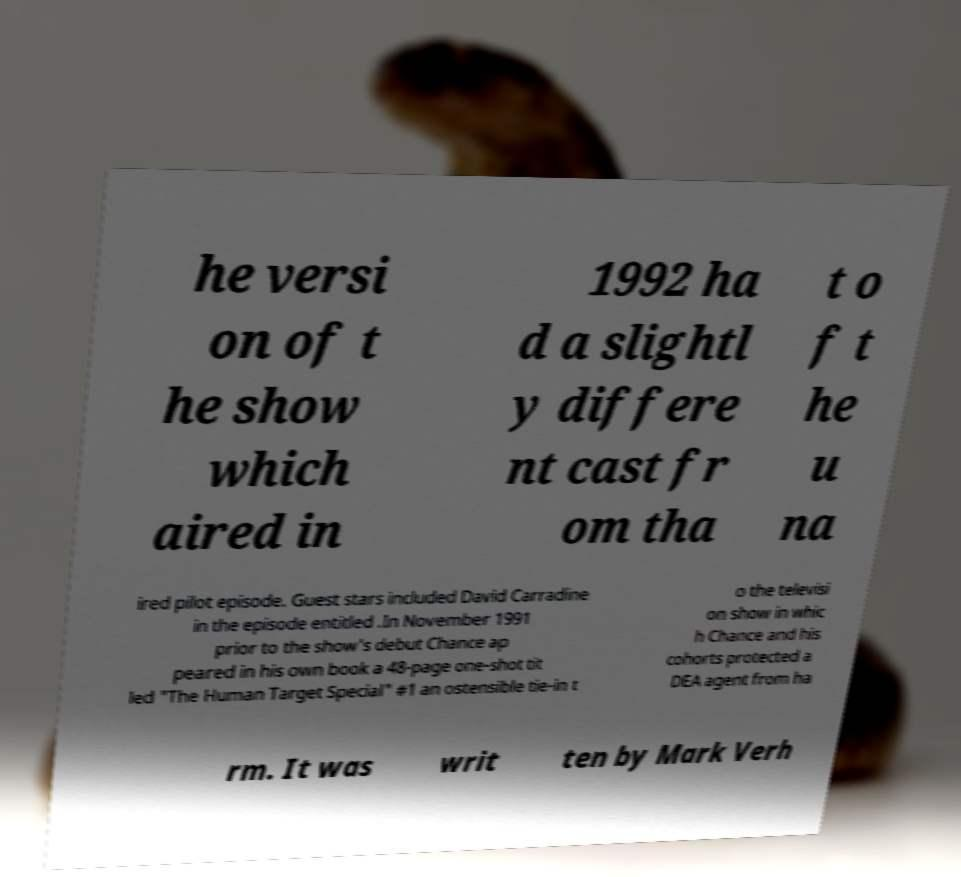What messages or text are displayed in this image? I need them in a readable, typed format. he versi on of t he show which aired in 1992 ha d a slightl y differe nt cast fr om tha t o f t he u na ired pilot episode. Guest stars included David Carradine in the episode entitled .In November 1991 prior to the show's debut Chance ap peared in his own book a 48-page one-shot tit led "The Human Target Special" #1 an ostensible tie-in t o the televisi on show in whic h Chance and his cohorts protected a DEA agent from ha rm. It was writ ten by Mark Verh 